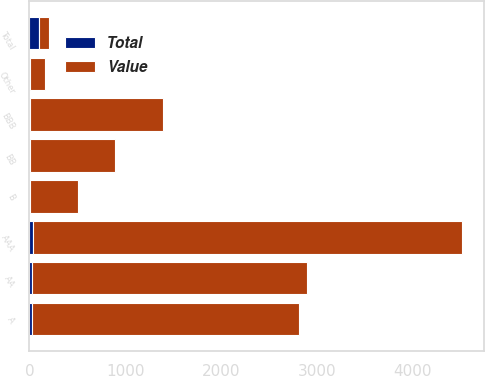<chart> <loc_0><loc_0><loc_500><loc_500><stacked_bar_chart><ecel><fcel>AAA<fcel>AA<fcel>A<fcel>BBB<fcel>BB<fcel>B<fcel>Other<fcel>Total<nl><fcel>Value<fcel>4483.6<fcel>2881.8<fcel>2798.7<fcel>1381.4<fcel>889.3<fcel>500.4<fcel>165.9<fcel>100<nl><fcel>Total<fcel>34.2<fcel>22<fcel>21.4<fcel>10.5<fcel>6.8<fcel>3.8<fcel>1.3<fcel>100<nl></chart> 